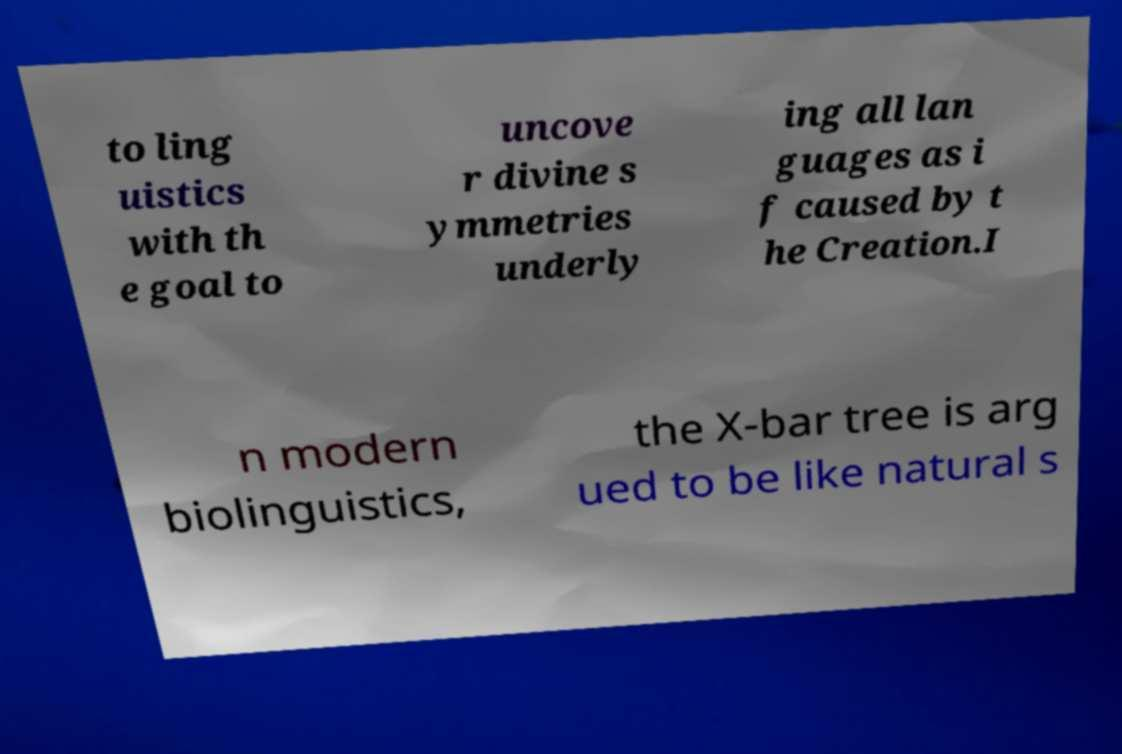Please identify and transcribe the text found in this image. to ling uistics with th e goal to uncove r divine s ymmetries underly ing all lan guages as i f caused by t he Creation.I n modern biolinguistics, the X-bar tree is arg ued to be like natural s 